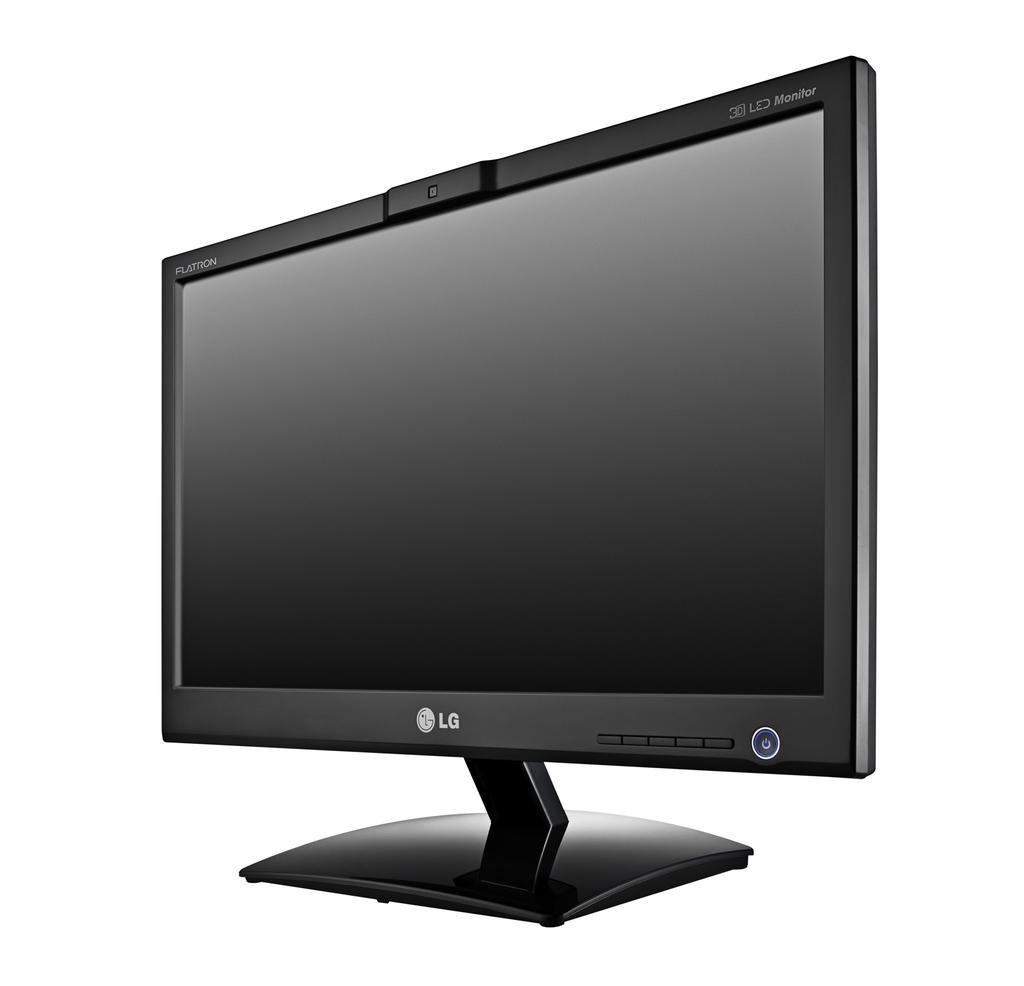Can you describe this image briefly? In this image we can see a monitor. The background is white in color. 